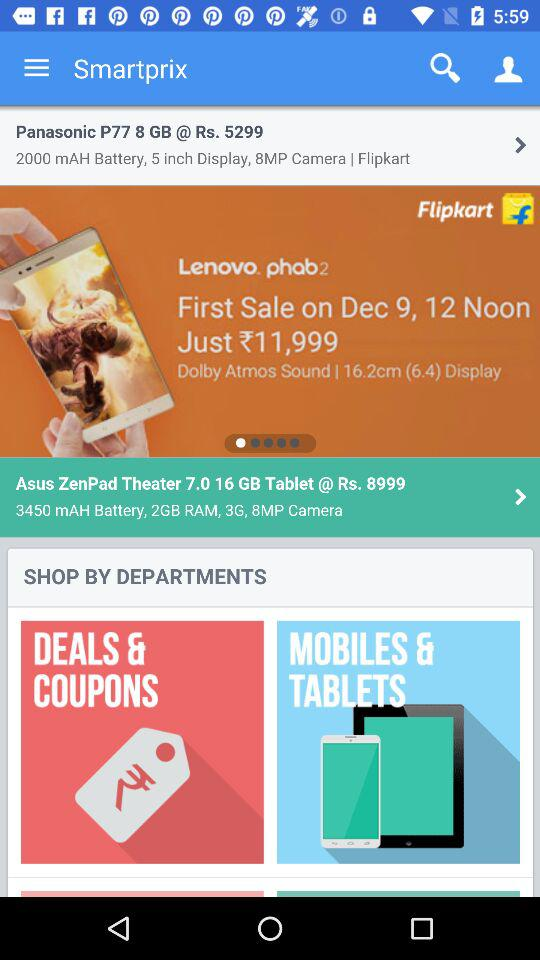How many megapixel cameras are there in the "Asus ZenPad Theatre"? It has an 8MP camera. 